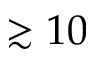<formula> <loc_0><loc_0><loc_500><loc_500>\gtrsim 1 0</formula> 